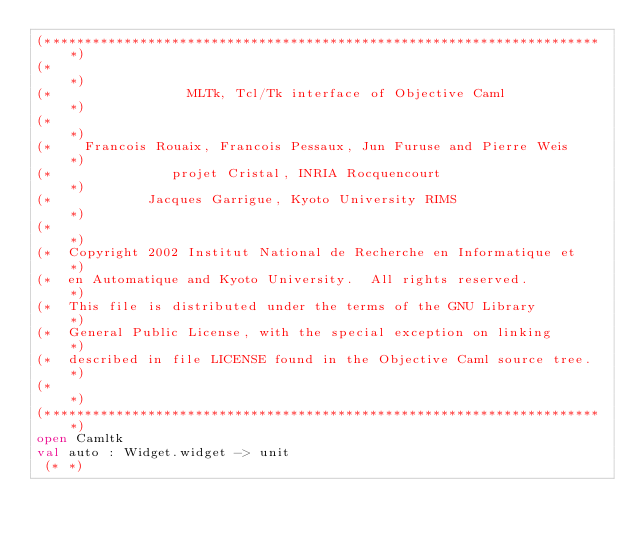<code> <loc_0><loc_0><loc_500><loc_500><_OCaml_>(***********************************************************************)
(*                                                                     *)
(*                 MLTk, Tcl/Tk interface of Objective Caml            *)
(*                                                                     *)
(*    Francois Rouaix, Francois Pessaux, Jun Furuse and Pierre Weis    *)
(*               projet Cristal, INRIA Rocquencourt                    *)
(*            Jacques Garrigue, Kyoto University RIMS                  *)
(*                                                                     *)
(*  Copyright 2002 Institut National de Recherche en Informatique et   *)
(*  en Automatique and Kyoto University.  All rights reserved.         *)
(*  This file is distributed under the terms of the GNU Library        *)
(*  General Public License, with the special exception on linking      *)
(*  described in file LICENSE found in the Objective Caml source tree. *)
(*                                                                     *)
(***********************************************************************)
open Camltk
val auto : Widget.widget -> unit
 (* *)
</code> 